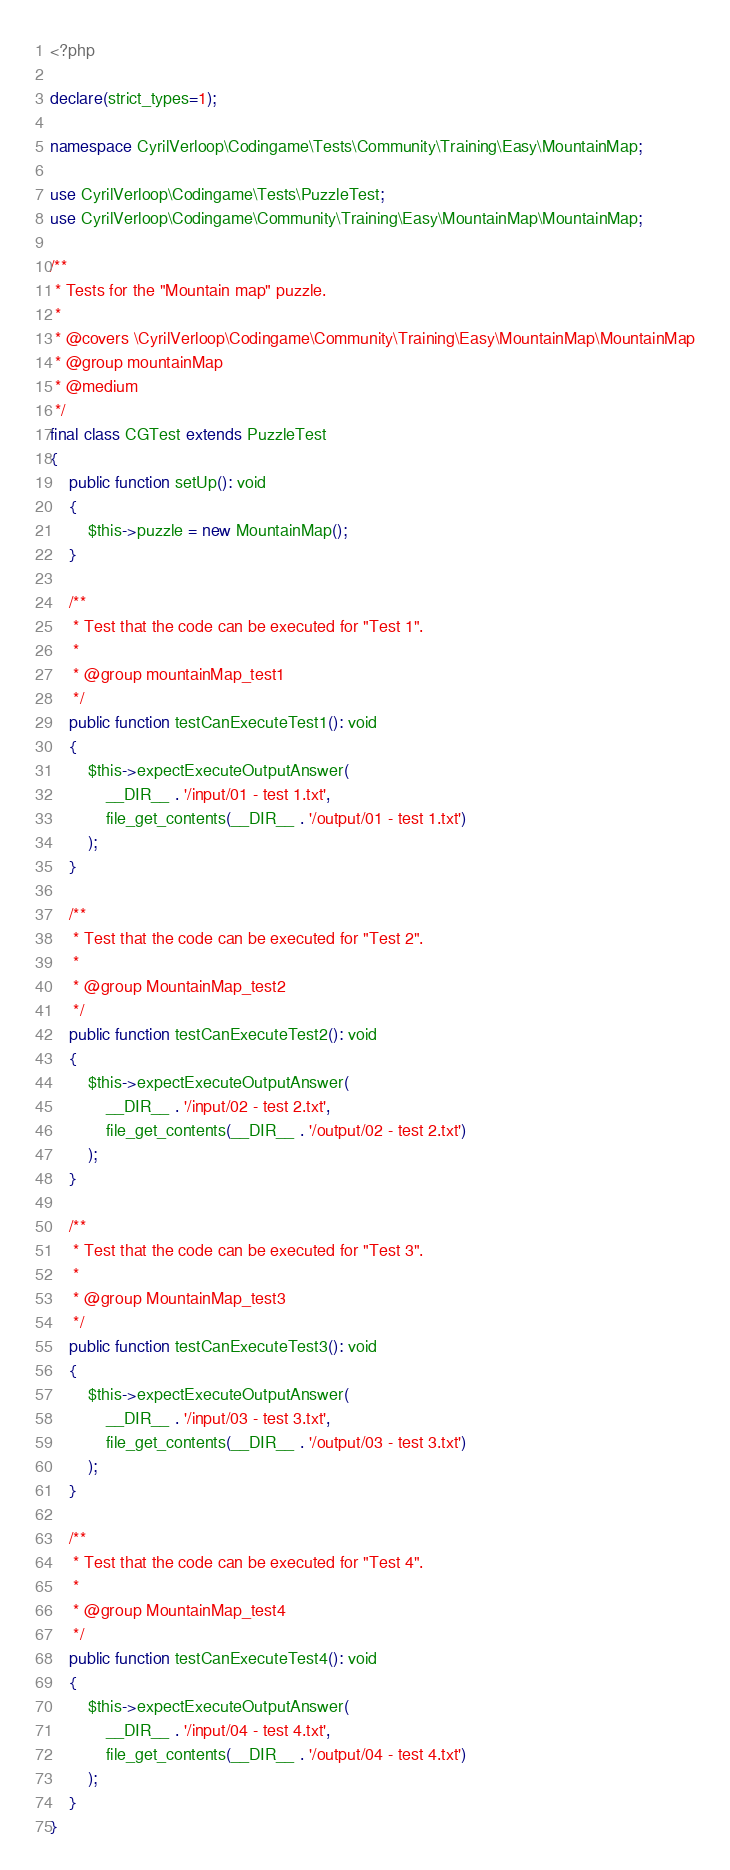Convert code to text. <code><loc_0><loc_0><loc_500><loc_500><_PHP_><?php

declare(strict_types=1);

namespace CyrilVerloop\Codingame\Tests\Community\Training\Easy\MountainMap;

use CyrilVerloop\Codingame\Tests\PuzzleTest;
use CyrilVerloop\Codingame\Community\Training\Easy\MountainMap\MountainMap;

/**
 * Tests for the "Mountain map" puzzle.
 *
 * @covers \CyrilVerloop\Codingame\Community\Training\Easy\MountainMap\MountainMap
 * @group mountainMap
 * @medium
 */
final class CGTest extends PuzzleTest
{
    public function setUp(): void
    {
        $this->puzzle = new MountainMap();
    }

    /**
     * Test that the code can be executed for "Test 1".
     *
     * @group mountainMap_test1
     */
    public function testCanExecuteTest1(): void
    {
        $this->expectExecuteOutputAnswer(
            __DIR__ . '/input/01 - test 1.txt',
            file_get_contents(__DIR__ . '/output/01 - test 1.txt')
        );
    }

    /**
     * Test that the code can be executed for "Test 2".
     *
     * @group MountainMap_test2
     */
    public function testCanExecuteTest2(): void
    {
        $this->expectExecuteOutputAnswer(
            __DIR__ . '/input/02 - test 2.txt',
            file_get_contents(__DIR__ . '/output/02 - test 2.txt')
        );
    }

    /**
     * Test that the code can be executed for "Test 3".
     *
     * @group MountainMap_test3
     */
    public function testCanExecuteTest3(): void
    {
        $this->expectExecuteOutputAnswer(
            __DIR__ . '/input/03 - test 3.txt',
            file_get_contents(__DIR__ . '/output/03 - test 3.txt')
        );
    }

    /**
     * Test that the code can be executed for "Test 4".
     *
     * @group MountainMap_test4
     */
    public function testCanExecuteTest4(): void
    {
        $this->expectExecuteOutputAnswer(
            __DIR__ . '/input/04 - test 4.txt',
            file_get_contents(__DIR__ . '/output/04 - test 4.txt')
        );
    }
}
</code> 